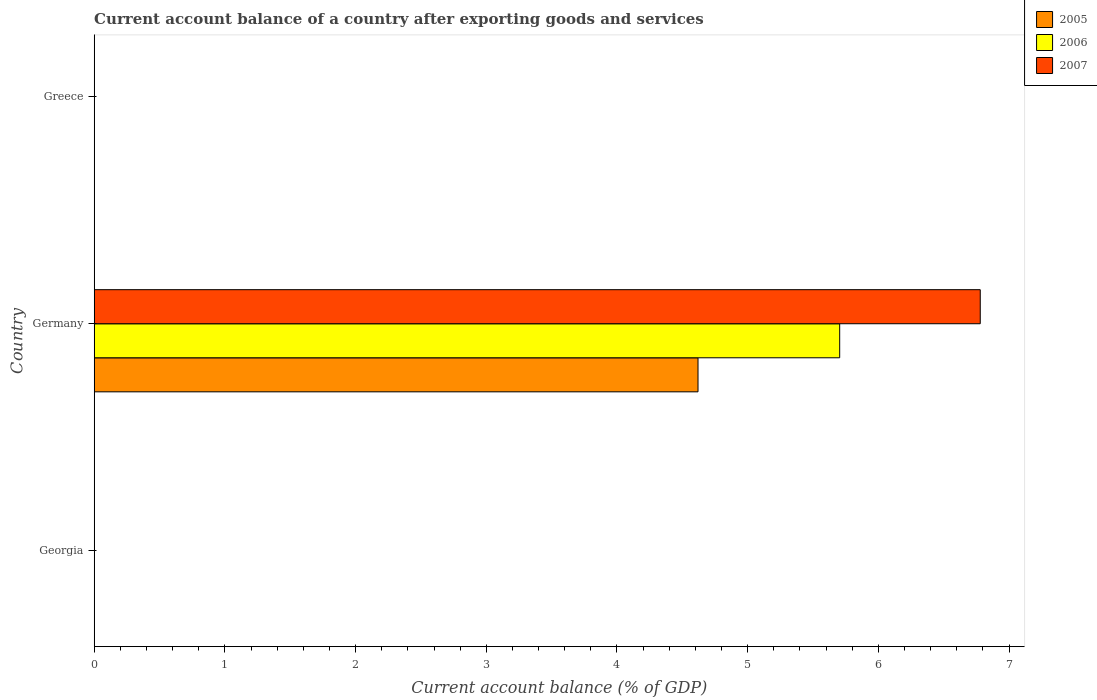Are the number of bars per tick equal to the number of legend labels?
Offer a very short reply. No. Are the number of bars on each tick of the Y-axis equal?
Offer a terse response. No. How many bars are there on the 2nd tick from the top?
Offer a terse response. 3. How many bars are there on the 3rd tick from the bottom?
Provide a succinct answer. 0. In how many cases, is the number of bars for a given country not equal to the number of legend labels?
Your answer should be very brief. 2. What is the account balance in 2006 in Greece?
Make the answer very short. 0. Across all countries, what is the maximum account balance in 2007?
Offer a very short reply. 6.78. What is the total account balance in 2006 in the graph?
Ensure brevity in your answer.  5.7. What is the difference between the account balance in 2005 in Greece and the account balance in 2007 in Germany?
Your answer should be compact. -6.78. What is the average account balance in 2005 per country?
Your response must be concise. 1.54. What is the difference between the highest and the lowest account balance in 2006?
Your answer should be very brief. 5.7. How many bars are there?
Ensure brevity in your answer.  3. How many countries are there in the graph?
Give a very brief answer. 3. Are the values on the major ticks of X-axis written in scientific E-notation?
Offer a very short reply. No. Does the graph contain any zero values?
Provide a short and direct response. Yes. Where does the legend appear in the graph?
Provide a succinct answer. Top right. How many legend labels are there?
Your response must be concise. 3. What is the title of the graph?
Your answer should be compact. Current account balance of a country after exporting goods and services. What is the label or title of the X-axis?
Offer a very short reply. Current account balance (% of GDP). What is the Current account balance (% of GDP) in 2006 in Georgia?
Give a very brief answer. 0. What is the Current account balance (% of GDP) of 2005 in Germany?
Make the answer very short. 4.62. What is the Current account balance (% of GDP) in 2006 in Germany?
Ensure brevity in your answer.  5.7. What is the Current account balance (% of GDP) of 2007 in Germany?
Your answer should be compact. 6.78. What is the Current account balance (% of GDP) of 2005 in Greece?
Provide a short and direct response. 0. What is the Current account balance (% of GDP) in 2006 in Greece?
Offer a very short reply. 0. Across all countries, what is the maximum Current account balance (% of GDP) in 2005?
Your answer should be very brief. 4.62. Across all countries, what is the maximum Current account balance (% of GDP) in 2006?
Your answer should be compact. 5.7. Across all countries, what is the maximum Current account balance (% of GDP) in 2007?
Your answer should be very brief. 6.78. Across all countries, what is the minimum Current account balance (% of GDP) of 2006?
Offer a very short reply. 0. What is the total Current account balance (% of GDP) in 2005 in the graph?
Your answer should be very brief. 4.62. What is the total Current account balance (% of GDP) of 2006 in the graph?
Your answer should be very brief. 5.7. What is the total Current account balance (% of GDP) of 2007 in the graph?
Make the answer very short. 6.78. What is the average Current account balance (% of GDP) in 2005 per country?
Make the answer very short. 1.54. What is the average Current account balance (% of GDP) in 2006 per country?
Give a very brief answer. 1.9. What is the average Current account balance (% of GDP) in 2007 per country?
Ensure brevity in your answer.  2.26. What is the difference between the Current account balance (% of GDP) in 2005 and Current account balance (% of GDP) in 2006 in Germany?
Offer a very short reply. -1.08. What is the difference between the Current account balance (% of GDP) of 2005 and Current account balance (% of GDP) of 2007 in Germany?
Give a very brief answer. -2.16. What is the difference between the Current account balance (% of GDP) in 2006 and Current account balance (% of GDP) in 2007 in Germany?
Offer a terse response. -1.08. What is the difference between the highest and the lowest Current account balance (% of GDP) in 2005?
Offer a terse response. 4.62. What is the difference between the highest and the lowest Current account balance (% of GDP) of 2006?
Your response must be concise. 5.7. What is the difference between the highest and the lowest Current account balance (% of GDP) in 2007?
Provide a succinct answer. 6.78. 